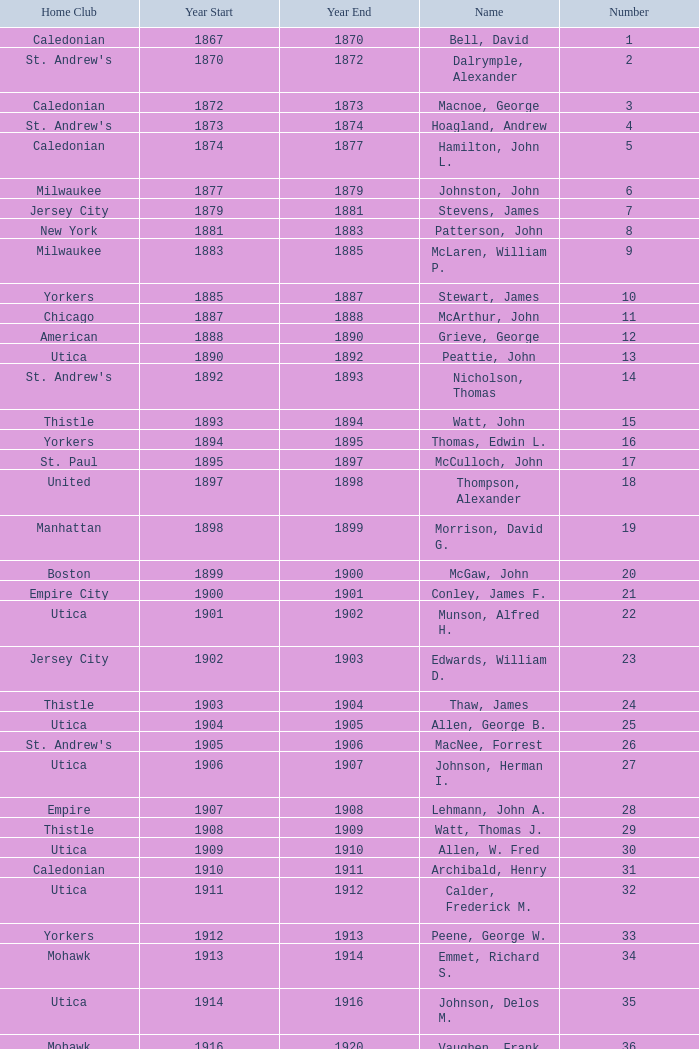Which Number has a Home Club of broomstones, and a Year End smaller than 1999? None. 